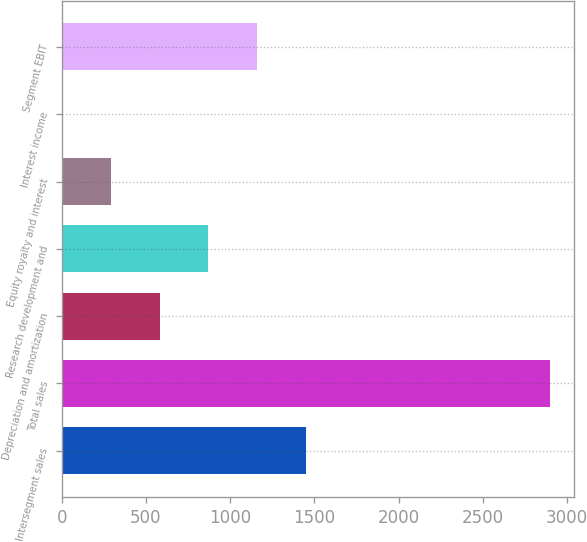Convert chart to OTSL. <chart><loc_0><loc_0><loc_500><loc_500><bar_chart><fcel>Intersegment sales<fcel>Total sales<fcel>Depreciation and amortization<fcel>Research development and<fcel>Equity royalty and interest<fcel>Interest income<fcel>Segment EBIT<nl><fcel>1449.5<fcel>2896<fcel>581.6<fcel>870.9<fcel>292.3<fcel>3<fcel>1160.2<nl></chart> 